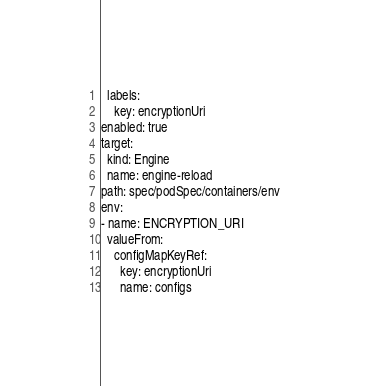Convert code to text. <code><loc_0><loc_0><loc_500><loc_500><_YAML_>  labels:
    key: encryptionUri
enabled: true
target:
  kind: Engine
  name: engine-reload
path: spec/podSpec/containers/env
env:
- name: ENCRYPTION_URI
  valueFrom:
    configMapKeyRef:
      key: encryptionUri
      name: configs
</code> 